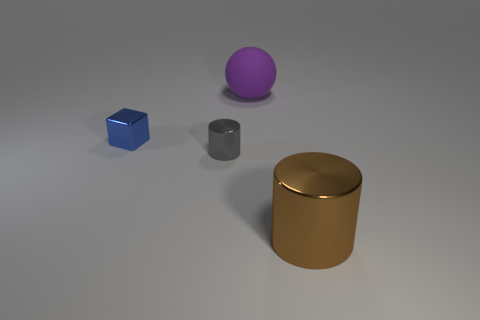There is a metallic thing that is on the right side of the blue block and to the left of the large brown cylinder; what is its size?
Provide a short and direct response. Small. There is another shiny thing that is the same shape as the tiny gray metallic object; what size is it?
Give a very brief answer. Large. How many objects are green rubber objects or tiny metallic things that are left of the gray cylinder?
Offer a very short reply. 1. What is the shape of the large brown thing?
Provide a short and direct response. Cylinder. What shape is the big thing that is in front of the large object that is behind the big brown metal cylinder?
Your response must be concise. Cylinder. What color is the cylinder that is the same material as the gray thing?
Your answer should be compact. Brown. Is there anything else that is the same size as the gray metal cylinder?
Provide a succinct answer. Yes. There is a big object in front of the small gray cylinder; does it have the same color as the metallic thing that is left of the gray thing?
Offer a very short reply. No. Is the number of cylinders to the left of the gray shiny object greater than the number of blue cubes in front of the big brown metal thing?
Offer a terse response. No. There is another metal thing that is the same shape as the small gray shiny object; what color is it?
Make the answer very short. Brown. 